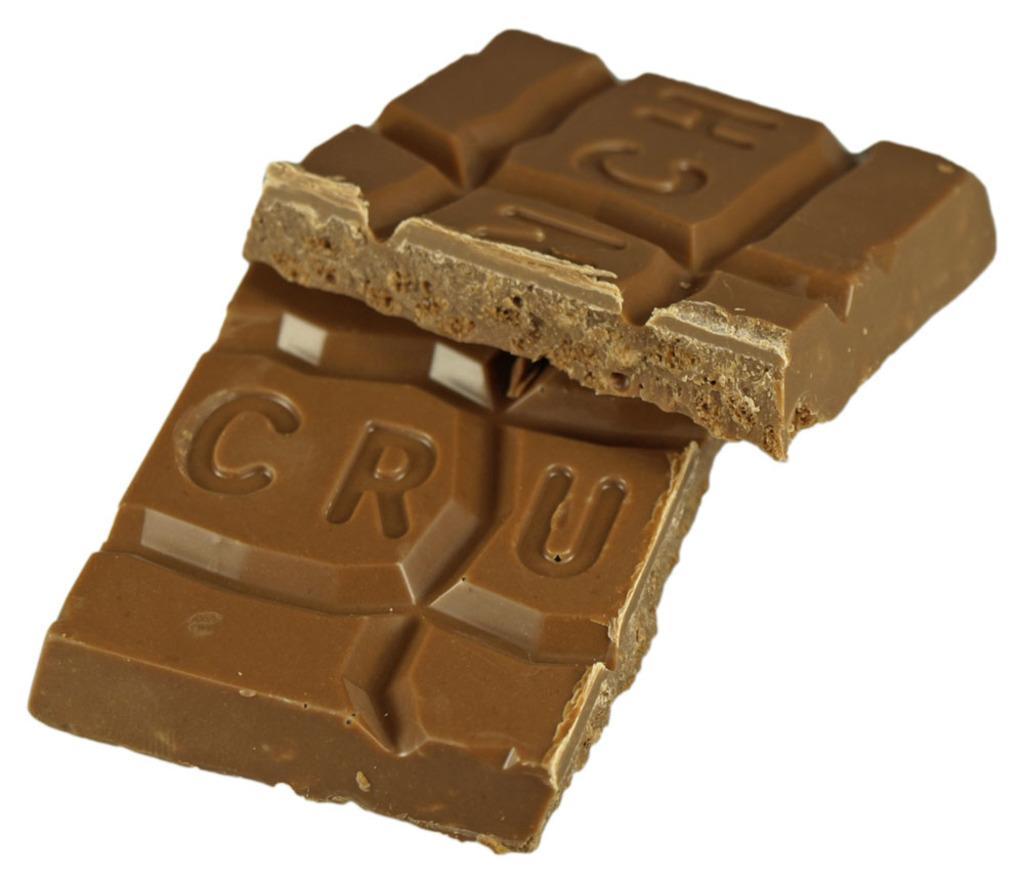How would you summarize this image in a sentence or two? In this picture I can see there is a chocolate placed on a white color surface. 